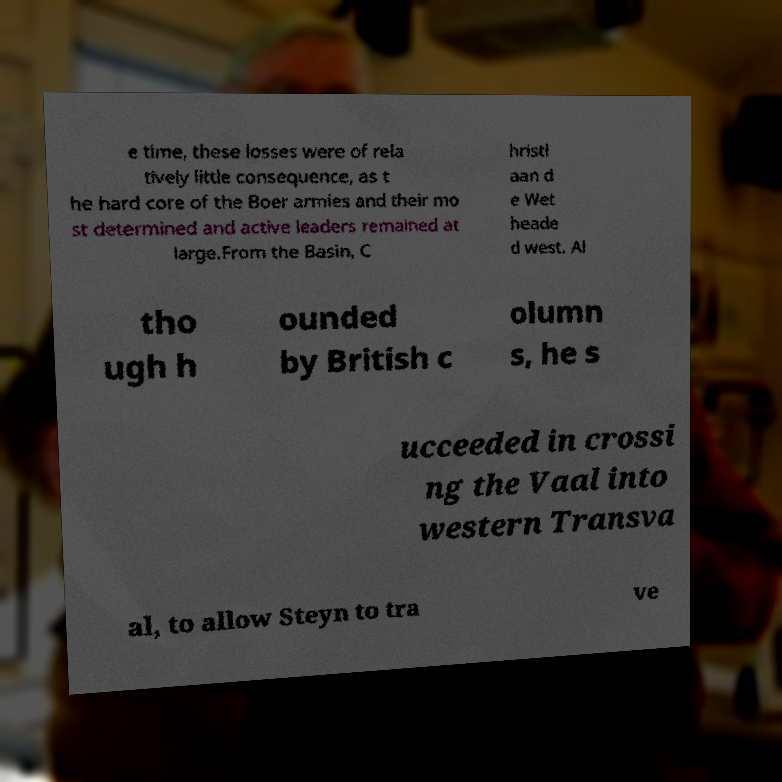Can you read and provide the text displayed in the image?This photo seems to have some interesting text. Can you extract and type it out for me? e time, these losses were of rela tively little consequence, as t he hard core of the Boer armies and their mo st determined and active leaders remained at large.From the Basin, C hristi aan d e Wet heade d west. Al tho ugh h ounded by British c olumn s, he s ucceeded in crossi ng the Vaal into western Transva al, to allow Steyn to tra ve 